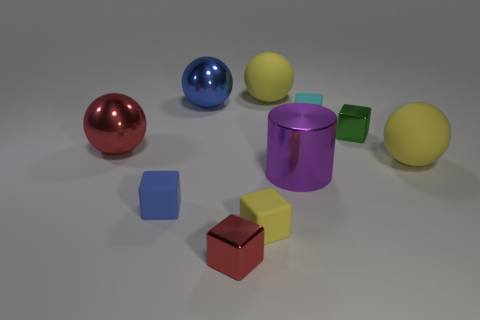Subtract all small cyan matte cubes. How many cubes are left? 4 Subtract all red spheres. How many spheres are left? 3 Subtract 3 cubes. How many cubes are left? 2 Subtract all balls. How many objects are left? 6 Subtract all cyan rubber cylinders. Subtract all cylinders. How many objects are left? 9 Add 5 blue metal spheres. How many blue metal spheres are left? 6 Add 3 metal cylinders. How many metal cylinders exist? 4 Subtract 0 red cylinders. How many objects are left? 10 Subtract all green balls. Subtract all yellow cubes. How many balls are left? 4 Subtract all blue balls. How many green cubes are left? 1 